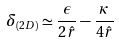<formula> <loc_0><loc_0><loc_500><loc_500>\delta _ { ( 2 D ) } \simeq \frac { \epsilon } { 2 \hat { r } } - \frac { \kappa } { 4 \hat { r } }</formula> 